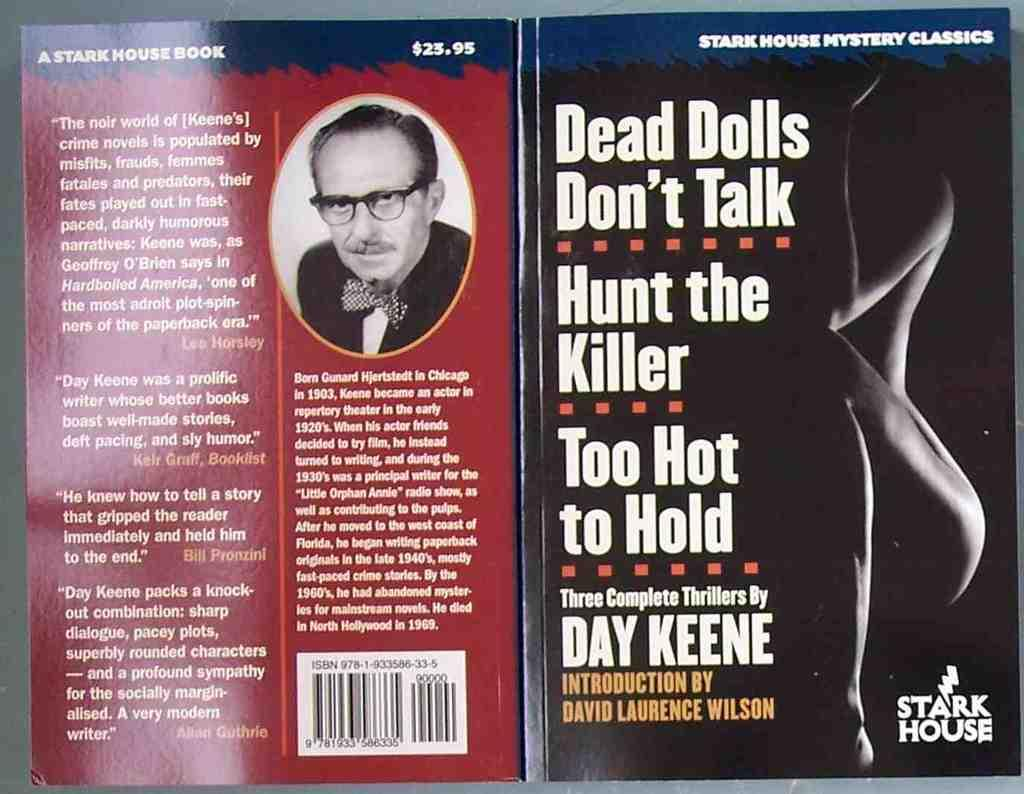Provide a one-sentence caption for the provided image. The front and back covers of a collection of three books by Day Keene. 